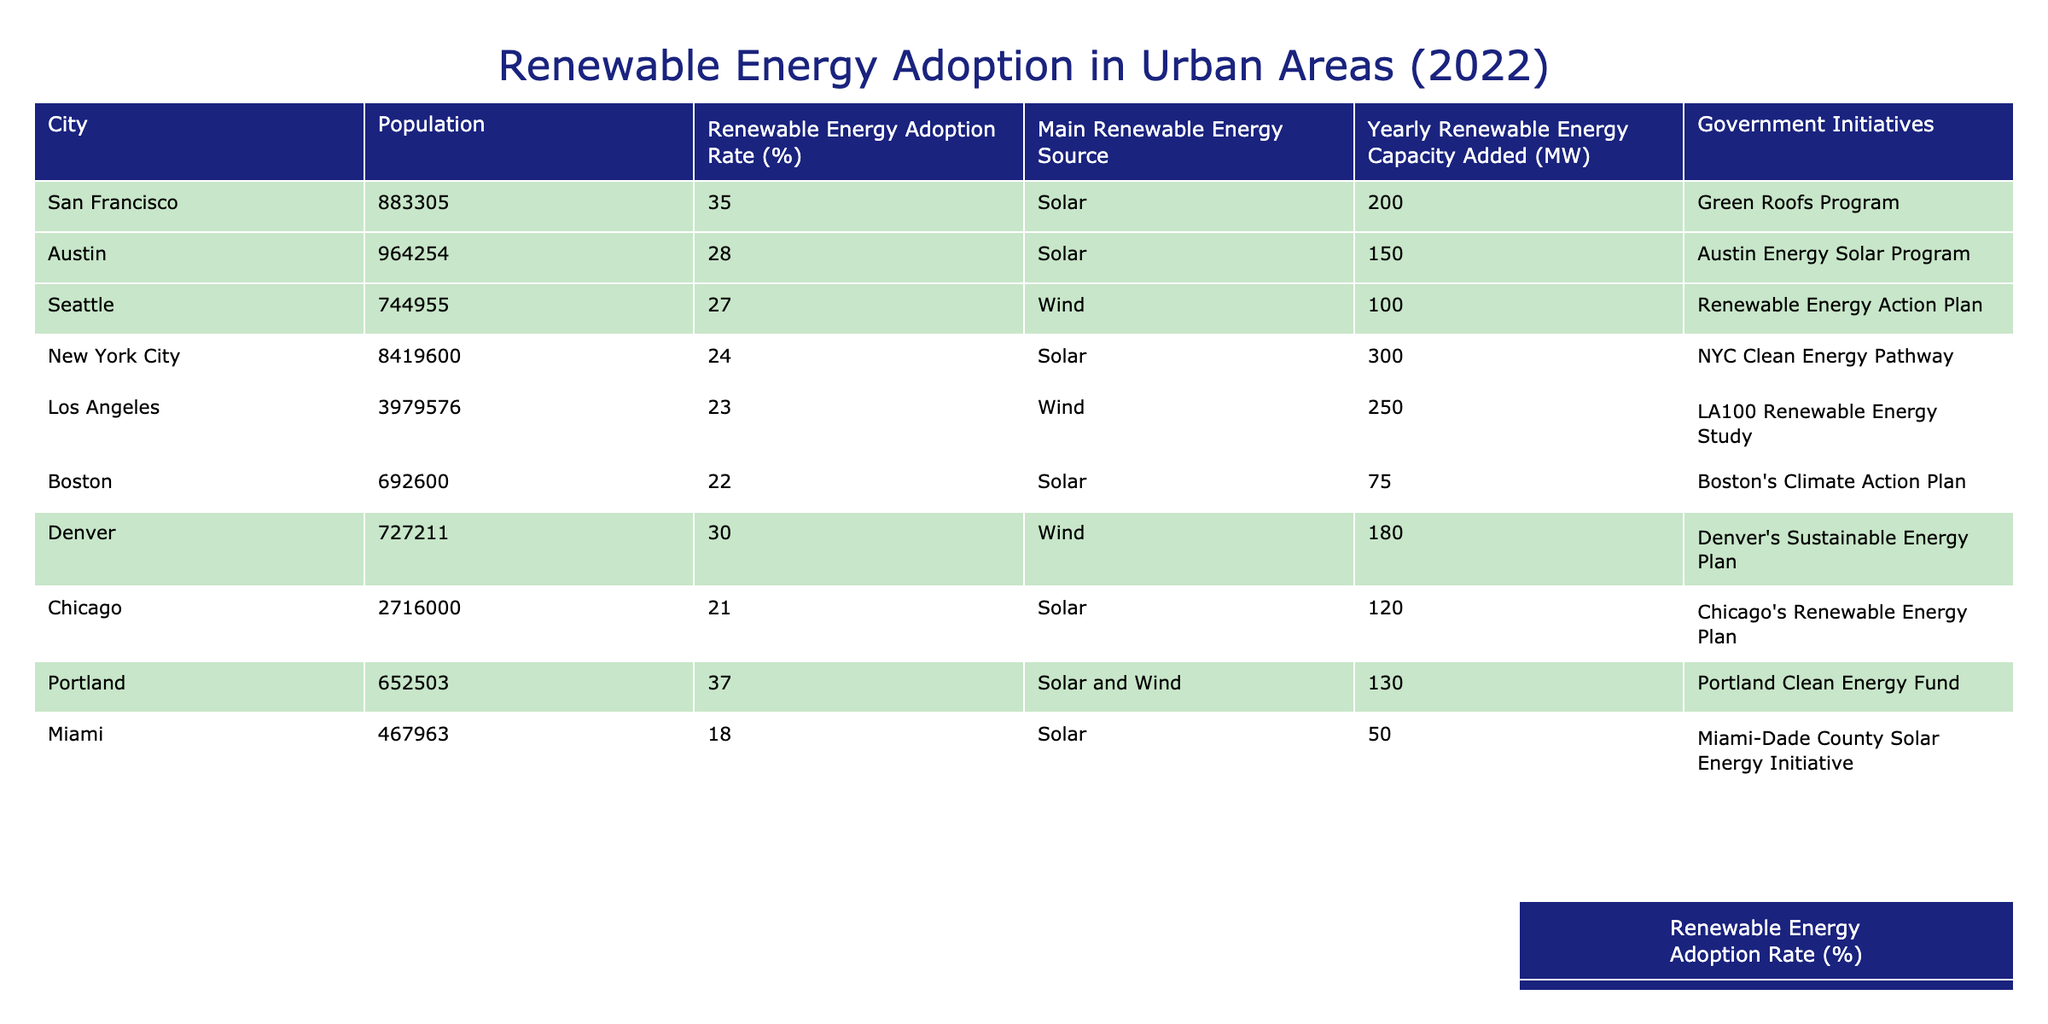What is the population of San Francisco? The table shows that the population of San Francisco is listed directly in the data. I can find this value in the "Population" column corresponding to San Francisco.
Answer: 883,305 Which city has the highest renewable energy adoption rate? By looking through the "Renewable Energy Adoption Rate (%)" column, I can see that Portland has the highest value at 37%.
Answer: Portland What is the main renewable energy source for Los Angeles? The table provides the main renewable energy source for each city. For Los Angeles, the main source is listed under "Main Renewable Energy Source" as Wind.
Answer: Wind How many megawatts of renewable energy capacity was added by New York City? I can refer to the "Yearly Renewable Energy Capacity Added (MW)" column for New York City, which lists the value directly as 300 MW.
Answer: 300 MW What is the average renewable energy adoption rate for all the cities listed? I will sum the renewable energy adoption rates for each city (35 + 28 + 27 + 24 + 23 + 22 + 30 + 21 + 37 + 18) =  275. There are 10 cities, so I divide by 10 to find the average: 275/10 = 27.5%.
Answer: 27.5% Which two cities added the most yearly renewable energy capacity in 2022? By comparing the "Yearly Renewable Energy Capacity Added (MW)" column for each city, I see that New York City (300 MW) and Los Angeles (250 MW) have the highest additions.
Answer: New York City and Los Angeles Is Miami's renewable energy adoption rate above or below the average? From my earlier calculation, the average adoption rate is 27.5%, and Miami's rate is 18%. Since 18% is less than 27.5%, I can conclude that Miami's rate is below average.
Answer: Below If combined, what is the total yearly renewable energy capacity added by San Francisco and Austin? To find the total, I first look at the values for each city: San Francisco added 200 MW, and Austin added 150 MW. I then sum these: 200 + 150 = 350 MW.
Answer: 350 MW How many city initiatives focus on solar energy? By checking the "Government Initiatives" column, I can count the number of initiatives that mention "Solar". From the cities listed, San Francisco, Austin, New York City, Boston, and Miami have solar initiatives. This makes a total of 5.
Answer: 5 What percentage of the listed cities have a renewable energy adoption rate of 25% or more? First, I identify the number of cities with an adoption rate of 25% or more: San Francisco, Austin, Denver, and Portland (4 cities). There are 10 cities in total, so I divide 4 by 10 and multiply by 100 to find the percentage: (4/10) * 100 = 40%.
Answer: 40% 